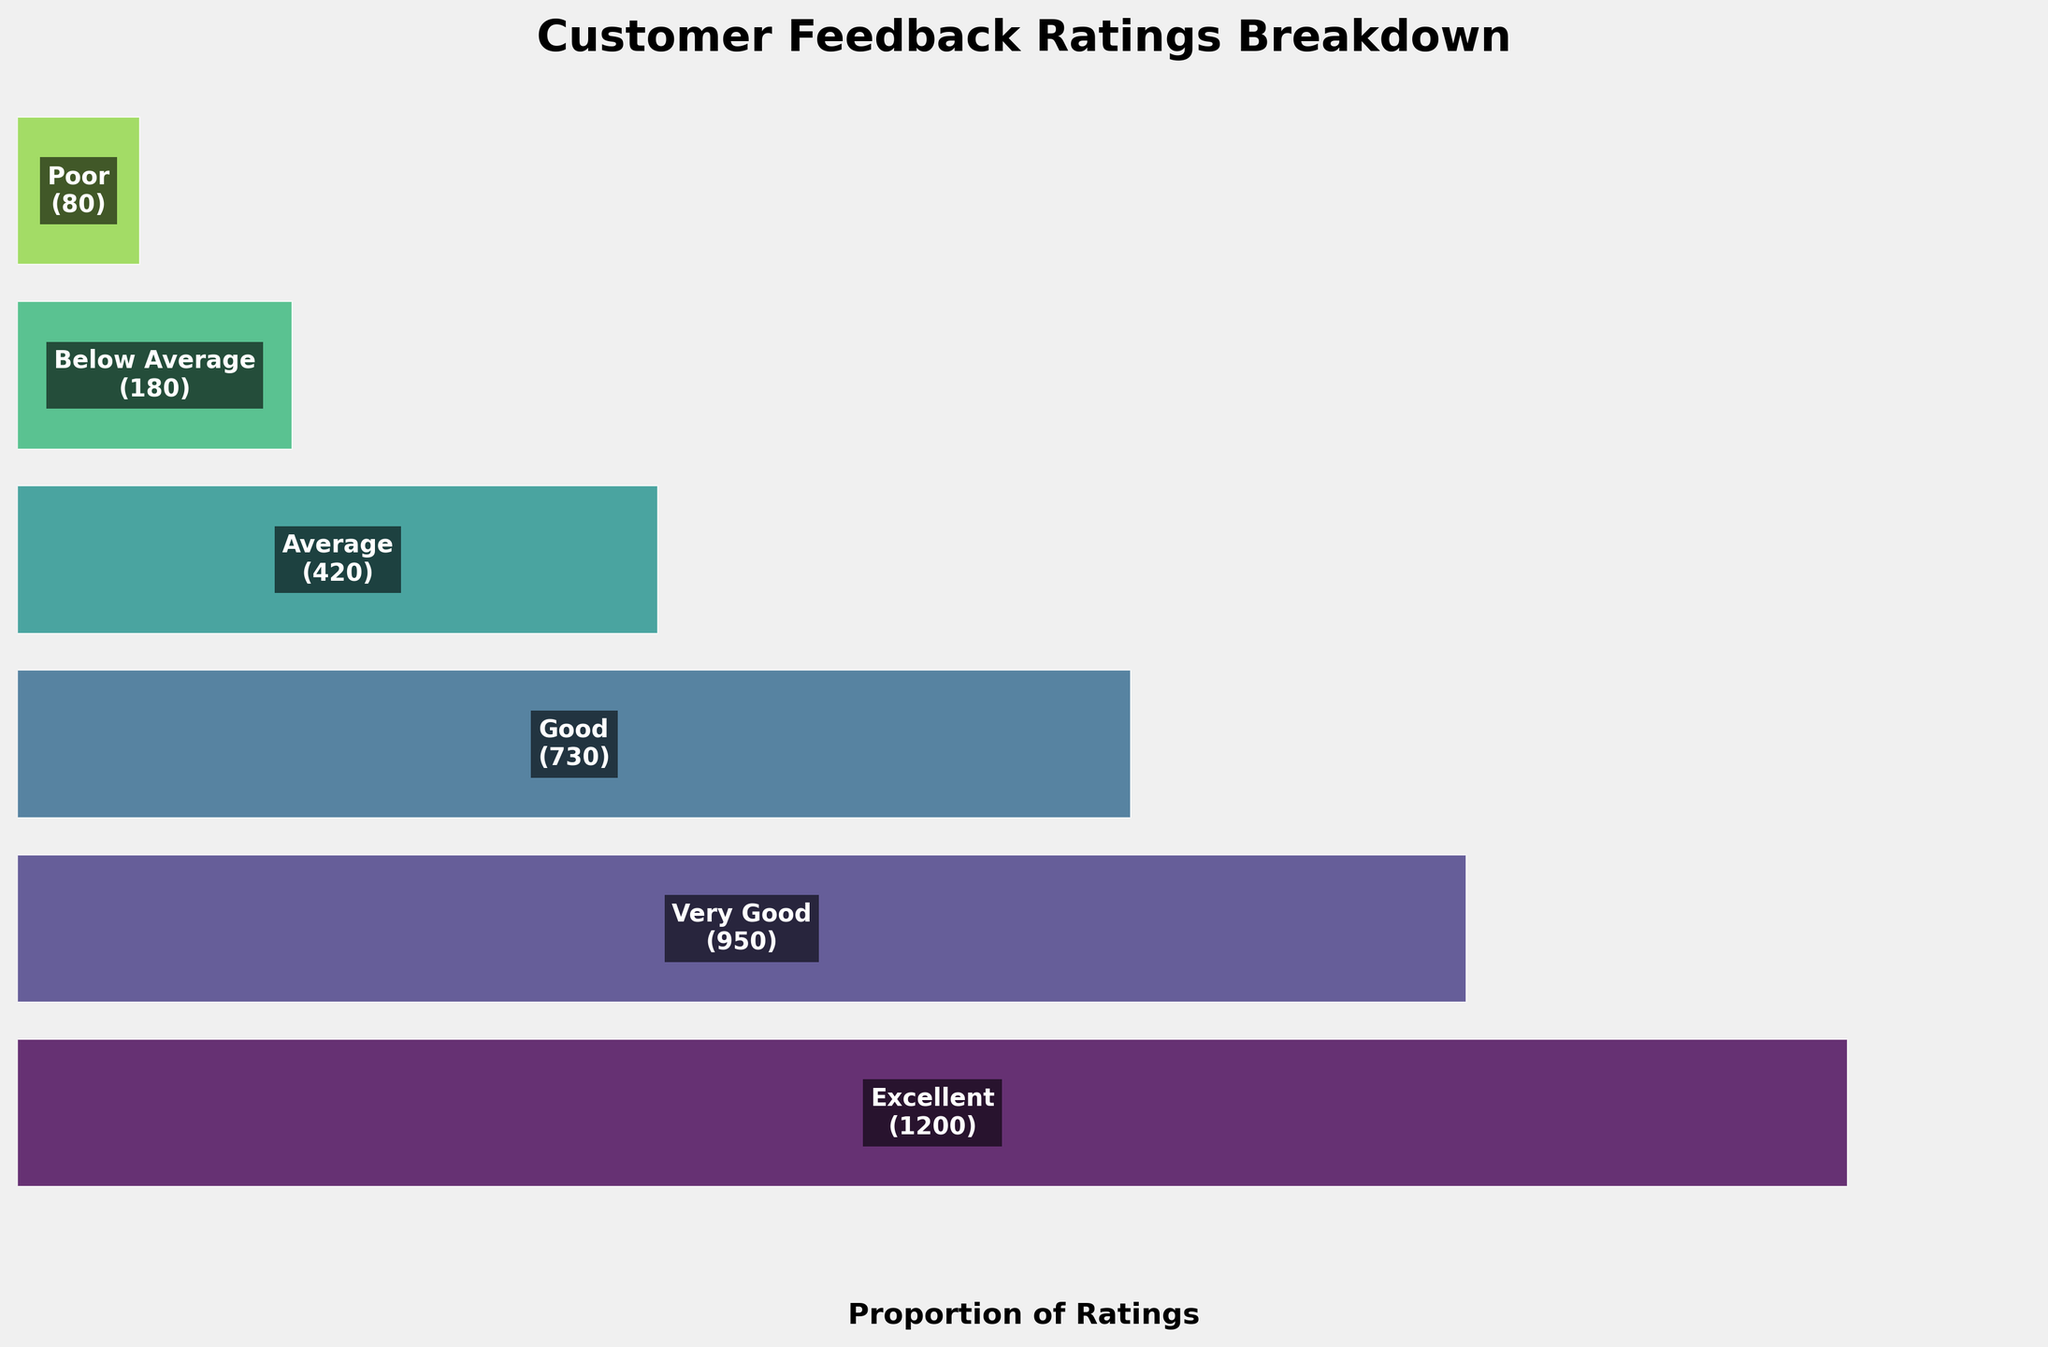What's the title of the funnel chart? The title of the chart can be found at the top of the figure. It’s designed to provide an overview of what the chart represents.
Answer: Customer Feedback Ratings Breakdown How many categories of feedback ratings are shown on the chart? By counting the different segments or layers in the chart, we can determine the number of categories being displayed.
Answer: 6 Which category has the highest count? By looking for the widest segment in the funnel chart at the top, we can identify the category with the highest count.
Answer: Excellent What is the total count of all the feedback ratings combined? The total count can be found by summing up the counts of all categories: 1200 + 950 + 730 + 420 + 180 + 80. This equals 3,560.
Answer: 3,560 Which category has the smallest count? By locating the narrowest segment in the funnel chart at the bottom, we can see which category has the smallest count.
Answer: Poor What is the proportion of 'Excellent' ratings to the total ratings? The proportion can be calculated by dividing the count of 'Excellent' ratings by the total count: 1200 / 3560 ≈ 0.3371 or 33.71%.
Answer: 33.71% Is the count of 'Very Good' ratings greater or less than that of 'Good' ratings? By comparing the widths of the 'Very Good' and 'Good' segments, we see that 'Very Good' has a wider segment than 'Good'. Hence, the count is greater.
Answer: Greater What is the difference in count between 'Average' and 'Below Average' ratings? Subtract the count of 'Below Average' from the count of 'Average’: 420 - 180 = 240.
Answer: 240 What percentage of the ratings are 'Poor'? To find the percentage, divide the count of 'Poor' ratings by the total count and multiply by 100: (80 / 3560) * 100 ≈ 2.25%.
Answer: 2.25% How does the count of 'Below Average' ratings compare to 'Excellent' ratings? Compare the 'Below Average' segment to the 'Excellent' segment; 'Below Average' has significantly fewer ratings than 'Excellent'.
Answer: Significantly fewer 